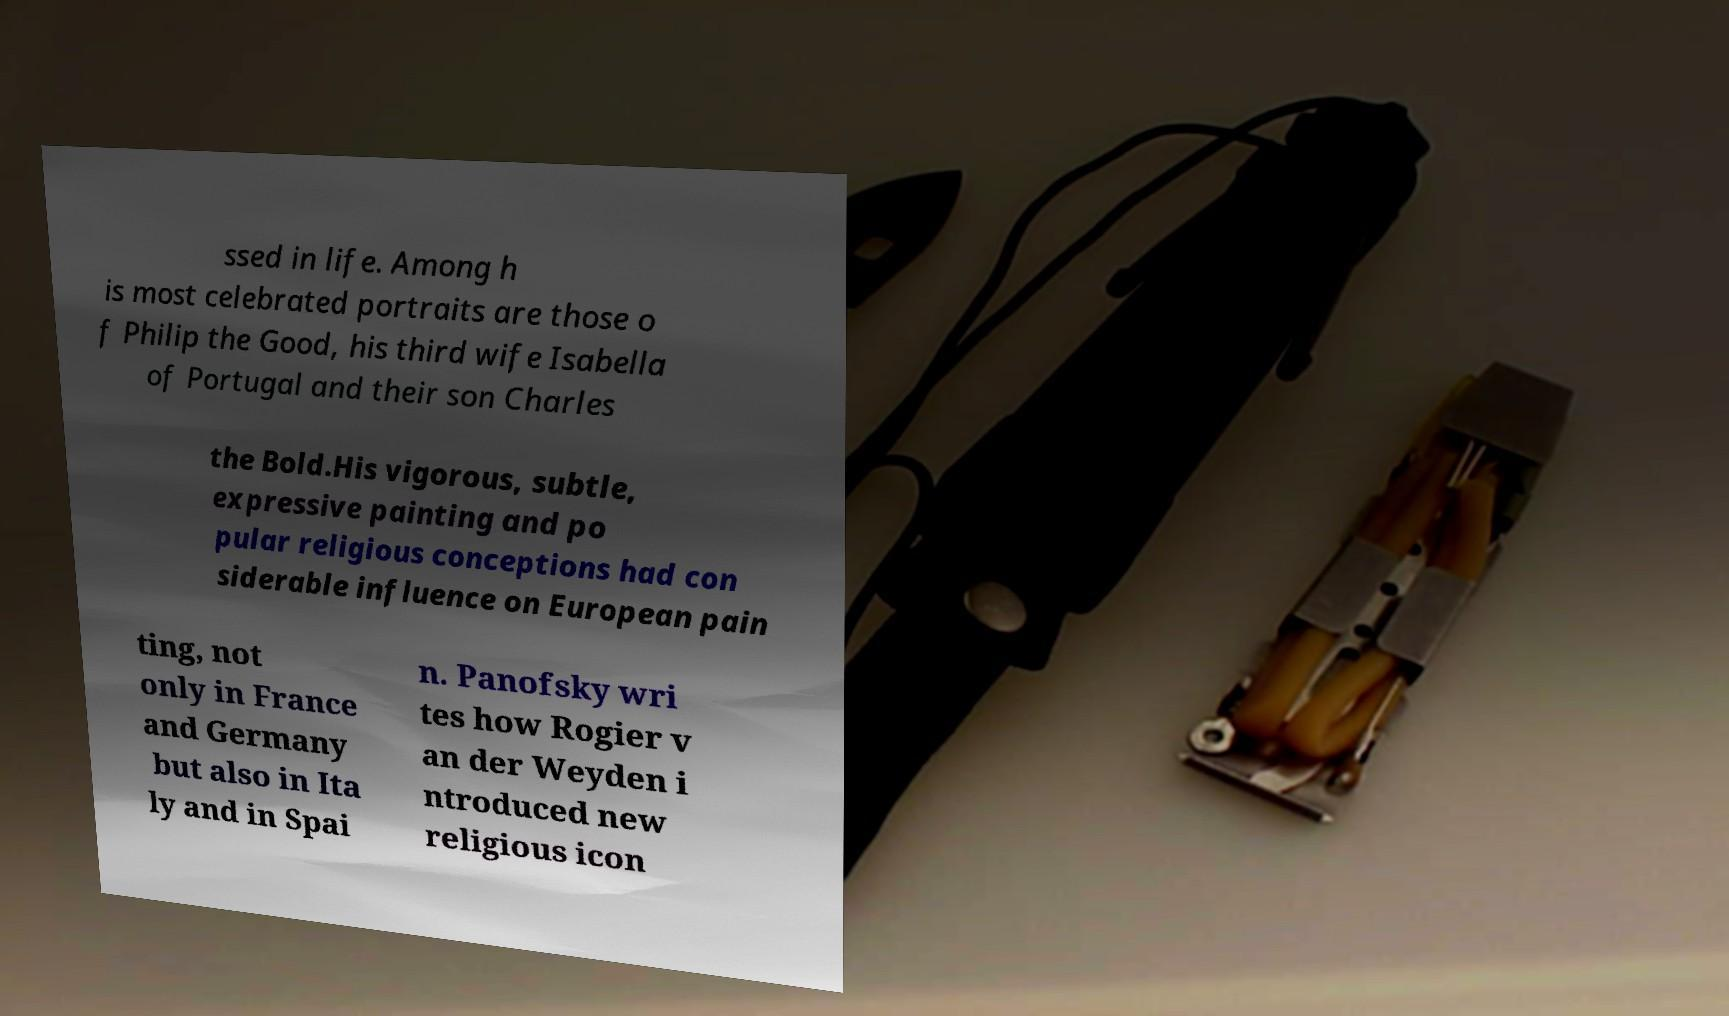Please identify and transcribe the text found in this image. ssed in life. Among h is most celebrated portraits are those o f Philip the Good, his third wife Isabella of Portugal and their son Charles the Bold.His vigorous, subtle, expressive painting and po pular religious conceptions had con siderable influence on European pain ting, not only in France and Germany but also in Ita ly and in Spai n. Panofsky wri tes how Rogier v an der Weyden i ntroduced new religious icon 